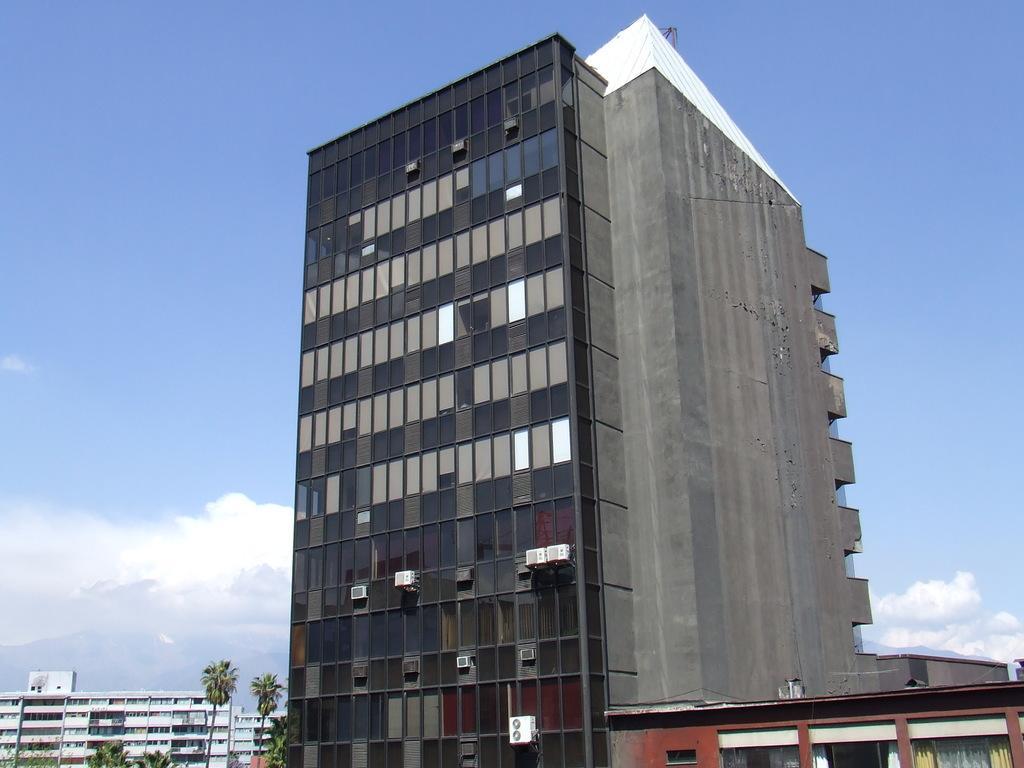Describe this image in one or two sentences. It is a very big building, on the left side there are trees. At the top it is the sky. 